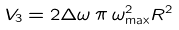Convert formula to latex. <formula><loc_0><loc_0><loc_500><loc_500>V _ { 3 } = 2 \Delta \omega \, \pi \, \omega _ { \max } ^ { 2 } R ^ { 2 }</formula> 